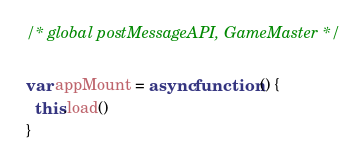<code> <loc_0><loc_0><loc_500><loc_500><_JavaScript_>/* global postMessageAPI, GameMaster */

var appMount = async function () {
  this.load()
}</code> 